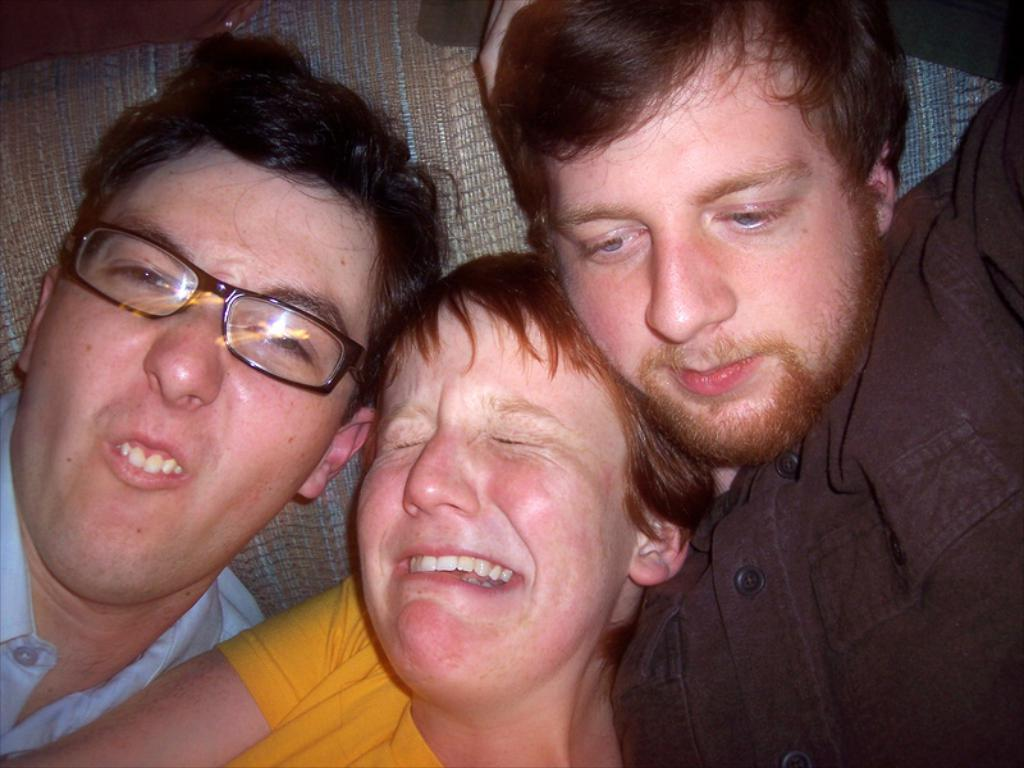How many people are present in the image? There are three people in the image. What can be observed about the clothing of the people in the image? The people are wearing different color dresses. Can you identify any accessories worn by the people in the image? One person is wearing specs. What type of basket is being used by the people in the image? There is no basket present in the image. How does the act of wearing specs end in the image? The act of wearing specs does not end in the image; it is a continuous action. 